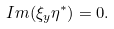Convert formula to latex. <formula><loc_0><loc_0><loc_500><loc_500>I m ( \xi _ { y } \eta ^ { * } ) = 0 .</formula> 